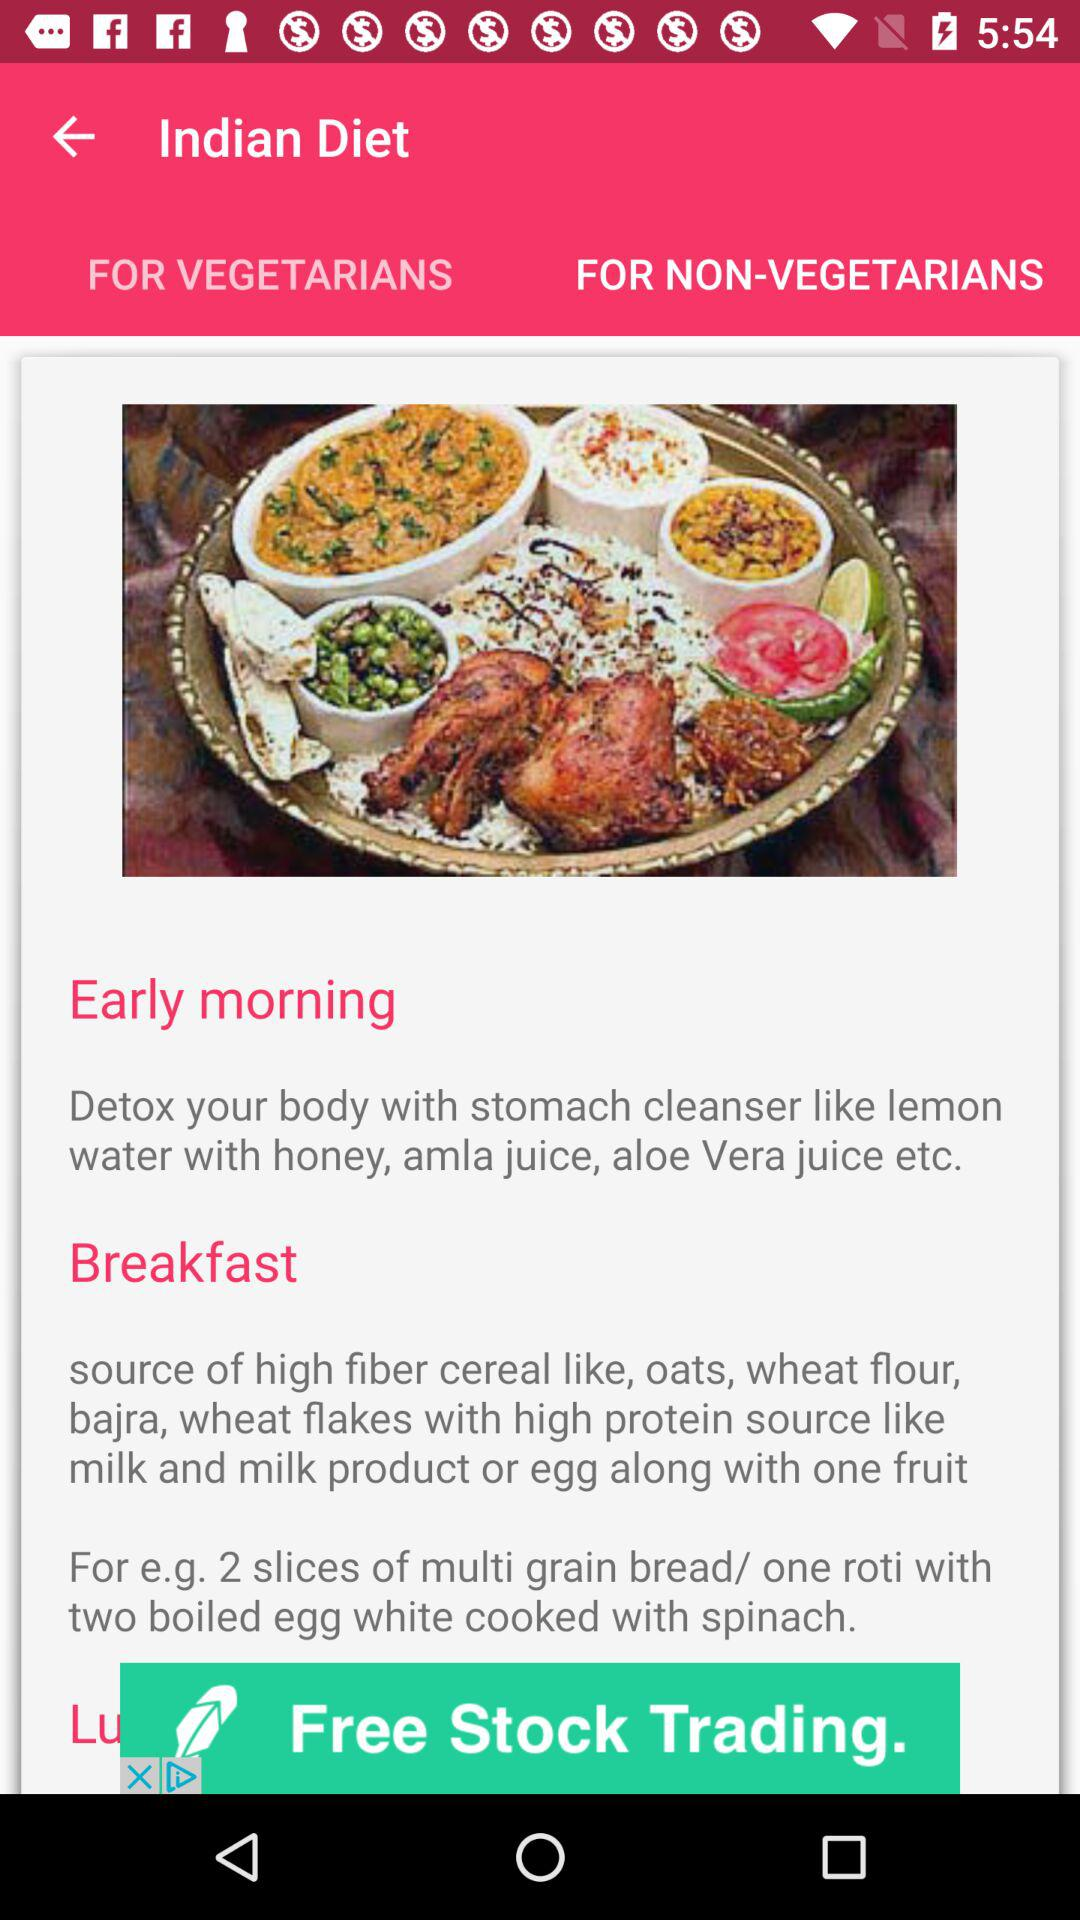What items are sources of high fiber? The items that are sources of high fiber are oats, wheat flour, bajra and wheat flakes. 